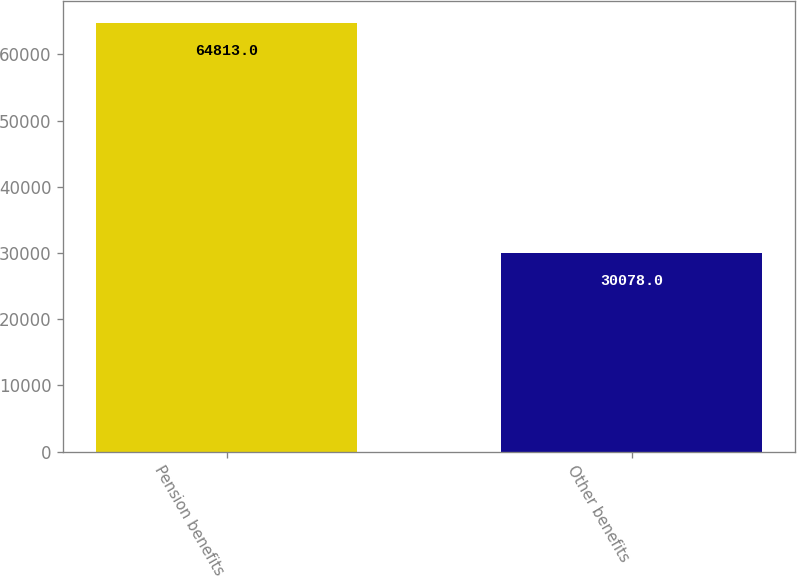Convert chart. <chart><loc_0><loc_0><loc_500><loc_500><bar_chart><fcel>Pension benefits<fcel>Other benefits<nl><fcel>64813<fcel>30078<nl></chart> 